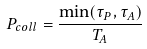Convert formula to latex. <formula><loc_0><loc_0><loc_500><loc_500>P _ { c o l l } = \frac { \min ( \tau _ { P } , \tau _ { A } ) } { T _ { A } }</formula> 